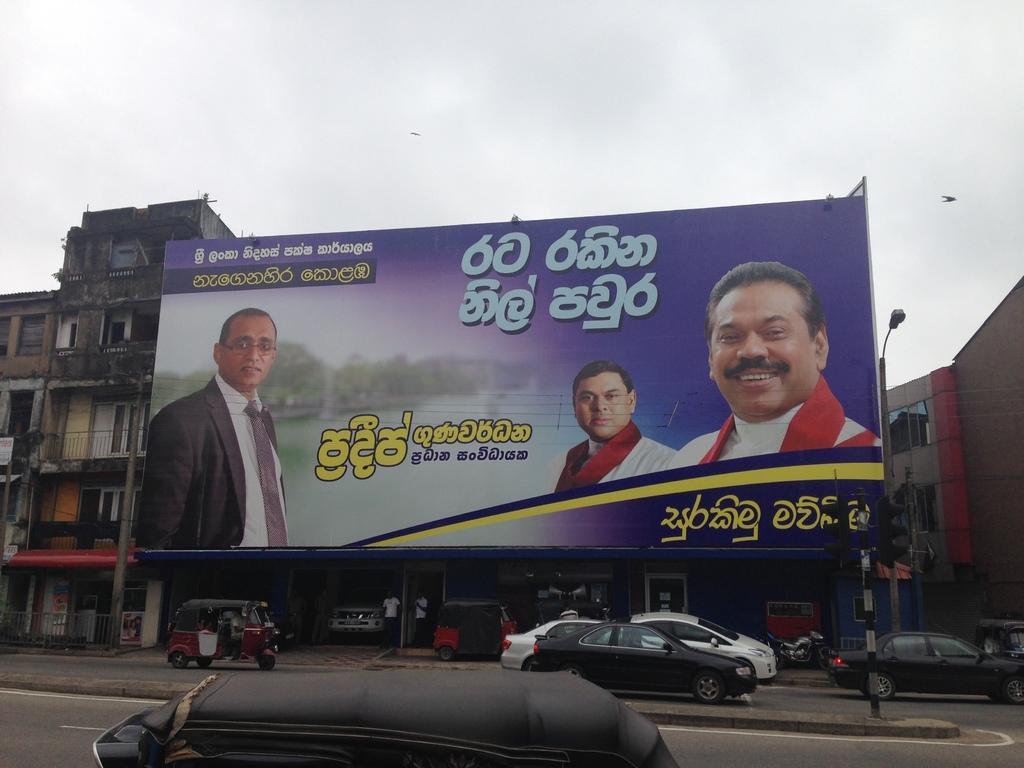In one or two sentences, can you explain what this image depicts? In the picture I can see buildings, vehicles on roads, a banner which has a photo of people and something written on it. In the background I can see a bird is flying in the air and the sky. 